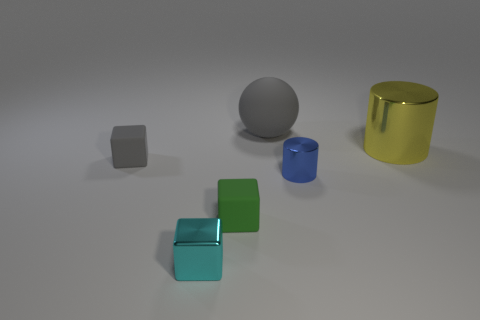Is there a object that has the same color as the sphere?
Provide a short and direct response. Yes. What is the shape of the matte thing that is the same color as the ball?
Ensure brevity in your answer.  Cube. What number of tiny green rubber blocks are right of the big object that is to the left of the yellow cylinder?
Offer a terse response. 0. How many large spheres have the same material as the big yellow thing?
Give a very brief answer. 0. There is a tiny metal cube; are there any small cyan shiny objects on the left side of it?
Make the answer very short. No. There is a metallic block that is the same size as the blue cylinder; what color is it?
Your response must be concise. Cyan. What number of objects are metal objects that are to the left of the yellow metal thing or gray objects?
Offer a very short reply. 4. How big is the object that is to the left of the tiny shiny cylinder and to the right of the green thing?
Offer a very short reply. Large. What number of other things are the same size as the blue metal thing?
Provide a succinct answer. 3. There is a tiny thing that is right of the large gray matte object on the left side of the tiny shiny thing behind the cyan metallic thing; what is its color?
Make the answer very short. Blue. 